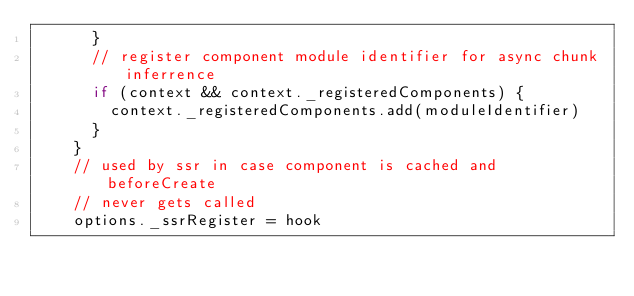Convert code to text. <code><loc_0><loc_0><loc_500><loc_500><_JavaScript_>      }
      // register component module identifier for async chunk inferrence
      if (context && context._registeredComponents) {
        context._registeredComponents.add(moduleIdentifier)
      }
    }
    // used by ssr in case component is cached and beforeCreate
    // never gets called
    options._ssrRegister = hook</code> 